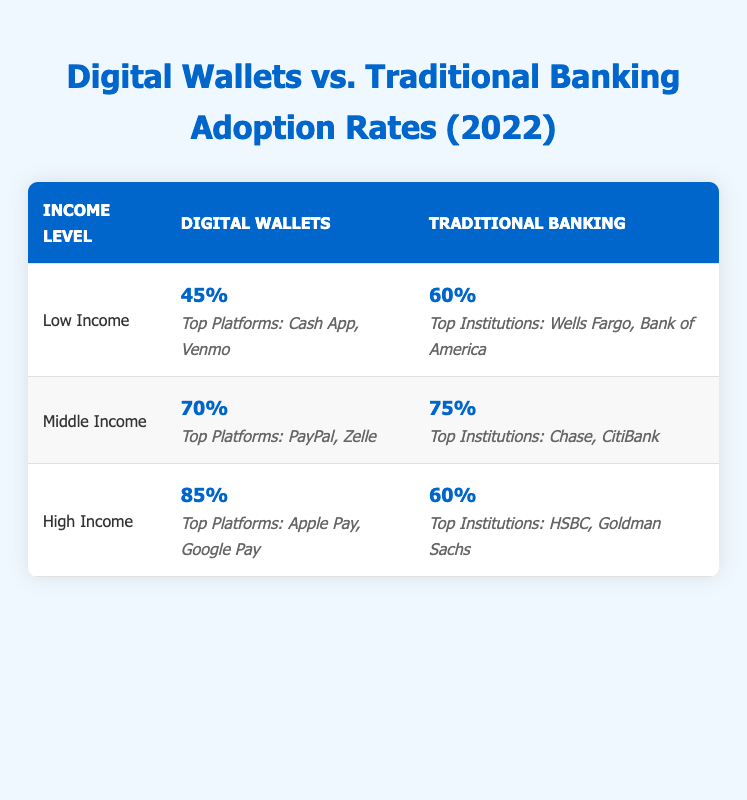What is the adoption rate of digital wallets for low-income individuals? From the table, the adoption rate for digital wallets under the low-income category is clearly listed as 45%.
Answer: 45% Which income level has the highest adoption rate for traditional banking services? Referring to the table, the highest adoption rate for traditional banking services is 75%, which corresponds to the middle-income group.
Answer: 75% Is it true that high-income individuals have a higher adoption rate for digital wallets than for traditional banking services? Yes, in the table, the high-income group has an adoption rate of 85% for digital wallets and only 60% for traditional banking services, confirming that the former is higher.
Answer: Yes What is the difference in adoption rates of digital wallets between the middle and low-income groups? The adoption rate for digital wallets in the middle-income group is 70%, while for the low-income group it is 45%. The difference can be calculated as 70% - 45% = 25%.
Answer: 25% What are the top platforms for digital wallets among high-income users? The table specifies that the top platforms for high-income individuals using digital wallets are Apple Pay and Google Pay.
Answer: Apple Pay, Google Pay What is the combined adoption rate of digital wallets for low and middle-income levels? The adoption rates for digital wallets in the low and middle-income levels are 45% and 70%, respectively. To find the combined rate, add these two rates: 45% + 70% = 115%. Since these are different groups, if interpreted as total users instead, the result reflects the sum, but it’s important to note this does not represent a valid average of users.
Answer: 115% Are Wells Fargo and Bank of America among the top institutions for traditional banking services for low-income individuals? Yes, the table confirms that Wells Fargo and Bank of America are listed as the top institutions for traditional banking services within the low-income category.
Answer: Yes What is the average adoption rate of digital wallets across all income levels? The adoption rates are 45% for low-income, 70% for middle-income, and 85% for high-income. To find the average, add these rates together: 45% + 70% + 85% = 200% and then divide by 3 (the number of groups), yielding an average adoption rate of 200% / 3 = approximately 66.67%.
Answer: 66.67% 